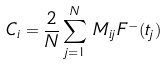<formula> <loc_0><loc_0><loc_500><loc_500>C _ { i } = \frac { 2 } { N } \sum _ { j = 1 } ^ { N } \, M _ { i j } \, F ^ { - } ( t _ { j } )</formula> 